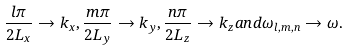Convert formula to latex. <formula><loc_0><loc_0><loc_500><loc_500>\frac { l \pi } { 2 L _ { x } } \to k _ { x } , \frac { m \pi } { 2 L _ { y } } \to k _ { y } , \frac { n \pi } { 2 L _ { z } } \to k _ { z } a n d \omega _ { l , m , n } \to \omega .</formula> 